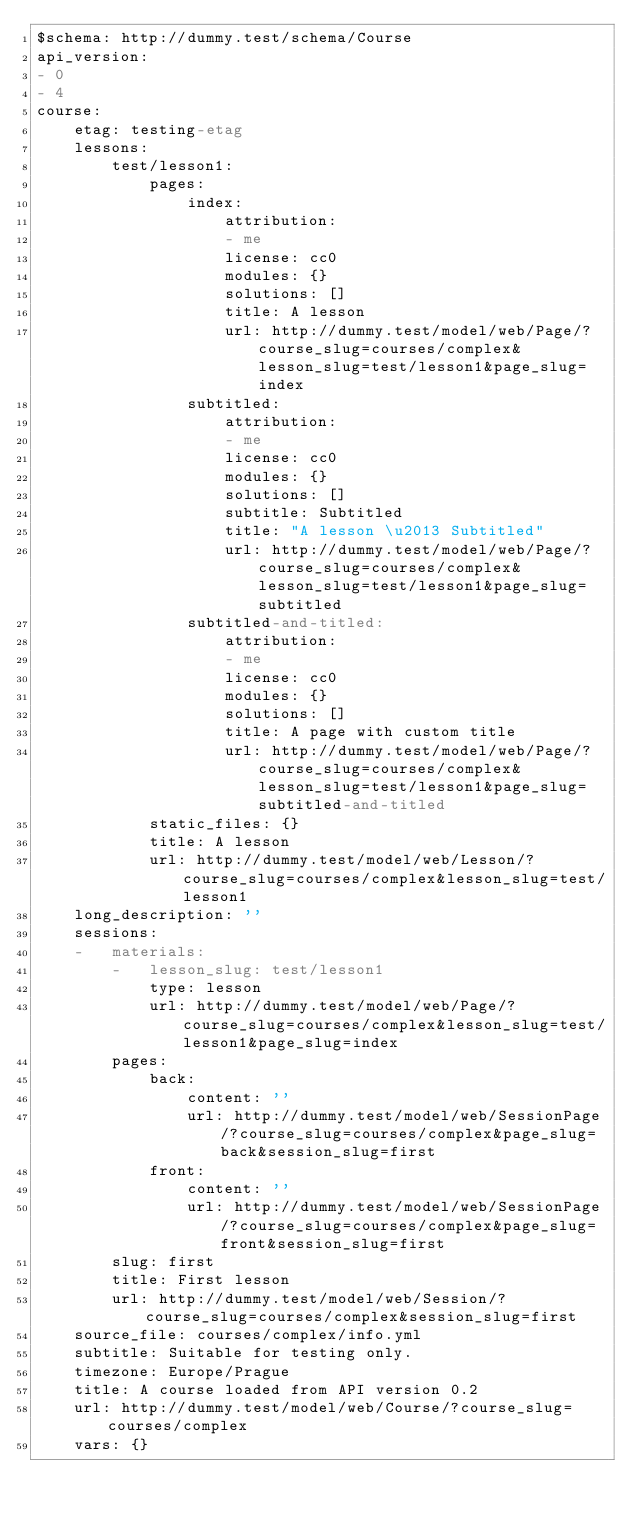Convert code to text. <code><loc_0><loc_0><loc_500><loc_500><_YAML_>$schema: http://dummy.test/schema/Course
api_version:
- 0
- 4
course:
    etag: testing-etag
    lessons:
        test/lesson1:
            pages:
                index:
                    attribution:
                    - me
                    license: cc0
                    modules: {}
                    solutions: []
                    title: A lesson
                    url: http://dummy.test/model/web/Page/?course_slug=courses/complex&lesson_slug=test/lesson1&page_slug=index
                subtitled:
                    attribution:
                    - me
                    license: cc0
                    modules: {}
                    solutions: []
                    subtitle: Subtitled
                    title: "A lesson \u2013 Subtitled"
                    url: http://dummy.test/model/web/Page/?course_slug=courses/complex&lesson_slug=test/lesson1&page_slug=subtitled
                subtitled-and-titled:
                    attribution:
                    - me
                    license: cc0
                    modules: {}
                    solutions: []
                    title: A page with custom title
                    url: http://dummy.test/model/web/Page/?course_slug=courses/complex&lesson_slug=test/lesson1&page_slug=subtitled-and-titled
            static_files: {}
            title: A lesson
            url: http://dummy.test/model/web/Lesson/?course_slug=courses/complex&lesson_slug=test/lesson1
    long_description: ''
    sessions:
    -   materials:
        -   lesson_slug: test/lesson1
            type: lesson
            url: http://dummy.test/model/web/Page/?course_slug=courses/complex&lesson_slug=test/lesson1&page_slug=index
        pages:
            back:
                content: ''
                url: http://dummy.test/model/web/SessionPage/?course_slug=courses/complex&page_slug=back&session_slug=first
            front:
                content: ''
                url: http://dummy.test/model/web/SessionPage/?course_slug=courses/complex&page_slug=front&session_slug=first
        slug: first
        title: First lesson
        url: http://dummy.test/model/web/Session/?course_slug=courses/complex&session_slug=first
    source_file: courses/complex/info.yml
    subtitle: Suitable for testing only.
    timezone: Europe/Prague
    title: A course loaded from API version 0.2
    url: http://dummy.test/model/web/Course/?course_slug=courses/complex
    vars: {}
</code> 